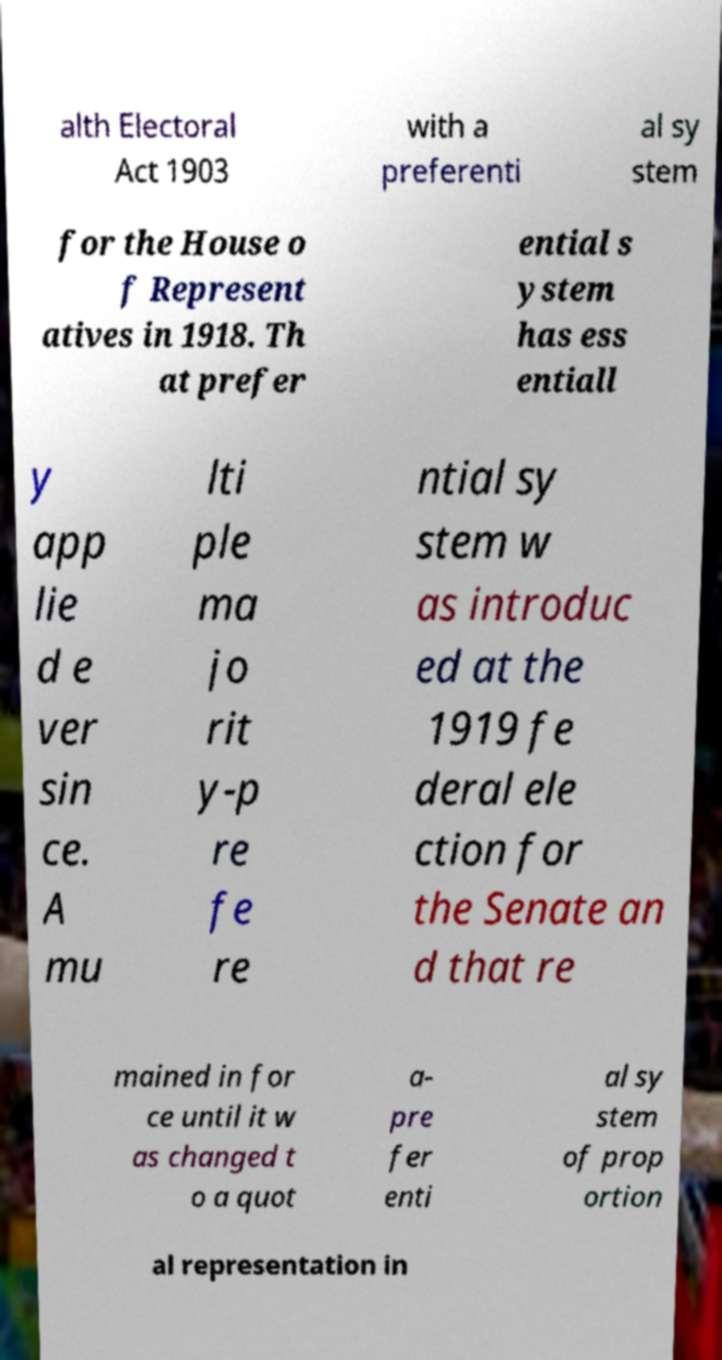I need the written content from this picture converted into text. Can you do that? alth Electoral Act 1903 with a preferenti al sy stem for the House o f Represent atives in 1918. Th at prefer ential s ystem has ess entiall y app lie d e ver sin ce. A mu lti ple ma jo rit y-p re fe re ntial sy stem w as introduc ed at the 1919 fe deral ele ction for the Senate an d that re mained in for ce until it w as changed t o a quot a- pre fer enti al sy stem of prop ortion al representation in 